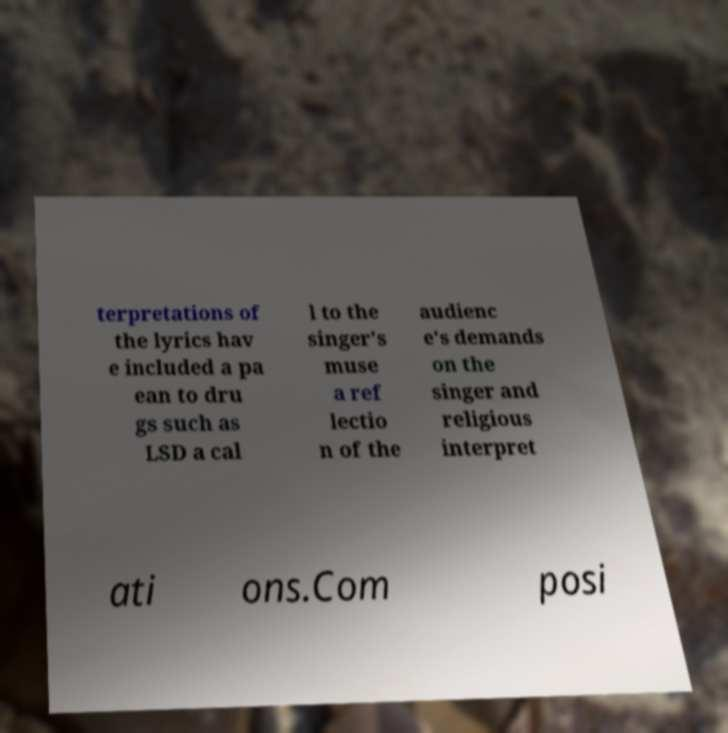Can you accurately transcribe the text from the provided image for me? terpretations of the lyrics hav e included a pa ean to dru gs such as LSD a cal l to the singer's muse a ref lectio n of the audienc e's demands on the singer and religious interpret ati ons.Com posi 